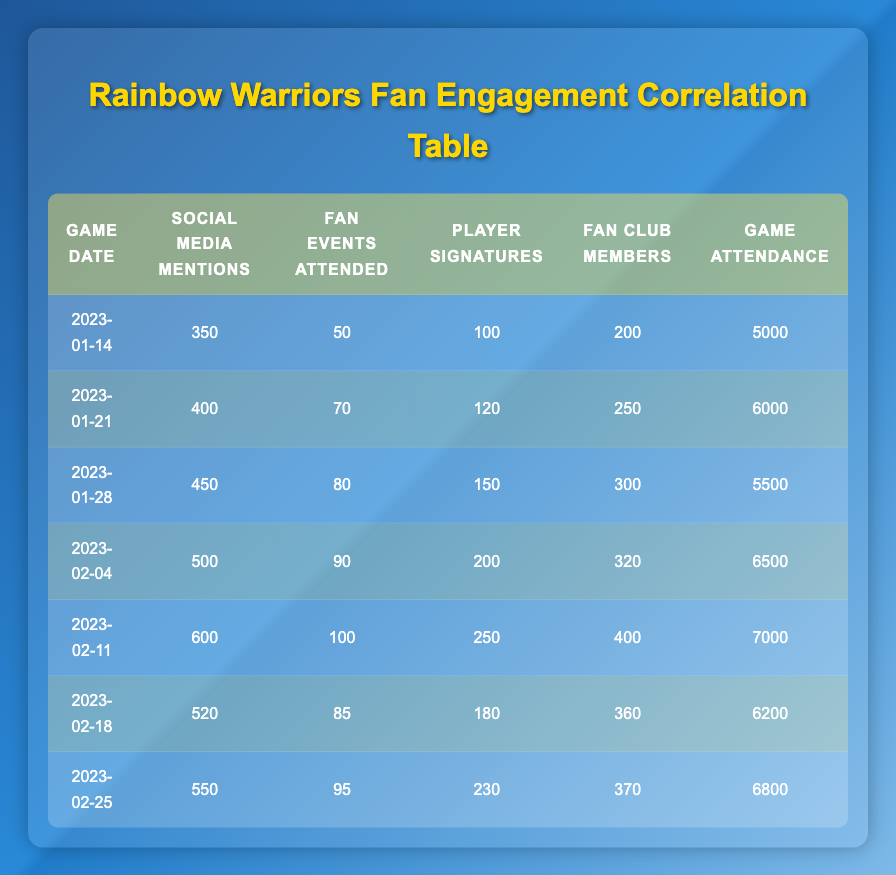What is the game attendance for the game on January 21, 2023? According to the table, the game on January 21, 2023, shows a game attendance of 6000.
Answer: 6000 Which game had the highest number of social media mentions? By comparing the "Social Media Mentions" column, the game on February 11, 2023, has the highest number at 600.
Answer: 600 How many total fan events were attended across all games listed? To find the total, we sum the "Fan Events Attended" column: 50 + 70 + 80 + 90 + 100 + 85 + 95 = 570.
Answer: 570 Is there any game with more than 7000 in attendance? Looking at the "Game Attendance" column, no game has attendance figures exceeding 7000 as the highest is 7000 on February 11, 2023.
Answer: No What is the average number of player signatures collected per game? To calculate the average, sum the "Player Signatures" values: 100 + 120 + 150 + 200 + 250 + 180 + 230 = 1230. Dividing by the total games (7), the average is 1230/7 ≈ 175.71.
Answer: 175.71 How many fan club members went to the game on February 18, 2023? The entry for February 18, 2023, lists 360 fan club members.
Answer: 360 Which date had an attendance of 5500? The date with an attendance of 5500 is January 28, 2023, as indicated in the table.
Answer: January 28, 2023 Was there a game where social media mentions were equal to 500 or more? Yes, games on January 28, February 4, February 11, February 18, and February 25 all had social media mentions of 500 or more.
Answer: Yes What is the difference in game attendance between the highest and the lowest attended games? The highest attendance is 7000 (February 11) and the lowest is 5000 (January 14). The difference is 7000 - 5000 = 2000.
Answer: 2000 